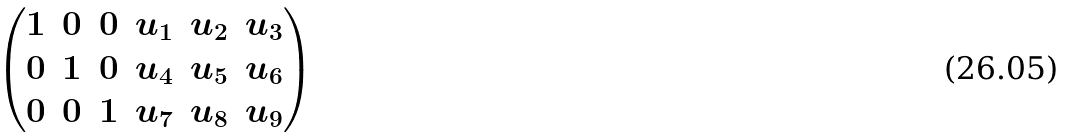<formula> <loc_0><loc_0><loc_500><loc_500>\begin{pmatrix} 1 & 0 & 0 & u _ { 1 } & u _ { 2 } & u _ { 3 } \\ 0 & 1 & 0 & u _ { 4 } & u _ { 5 } & u _ { 6 } \\ 0 & 0 & 1 & u _ { 7 } & u _ { 8 } & u _ { 9 } \end{pmatrix}</formula> 